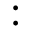<formula> <loc_0><loc_0><loc_500><loc_500>\colon</formula> 